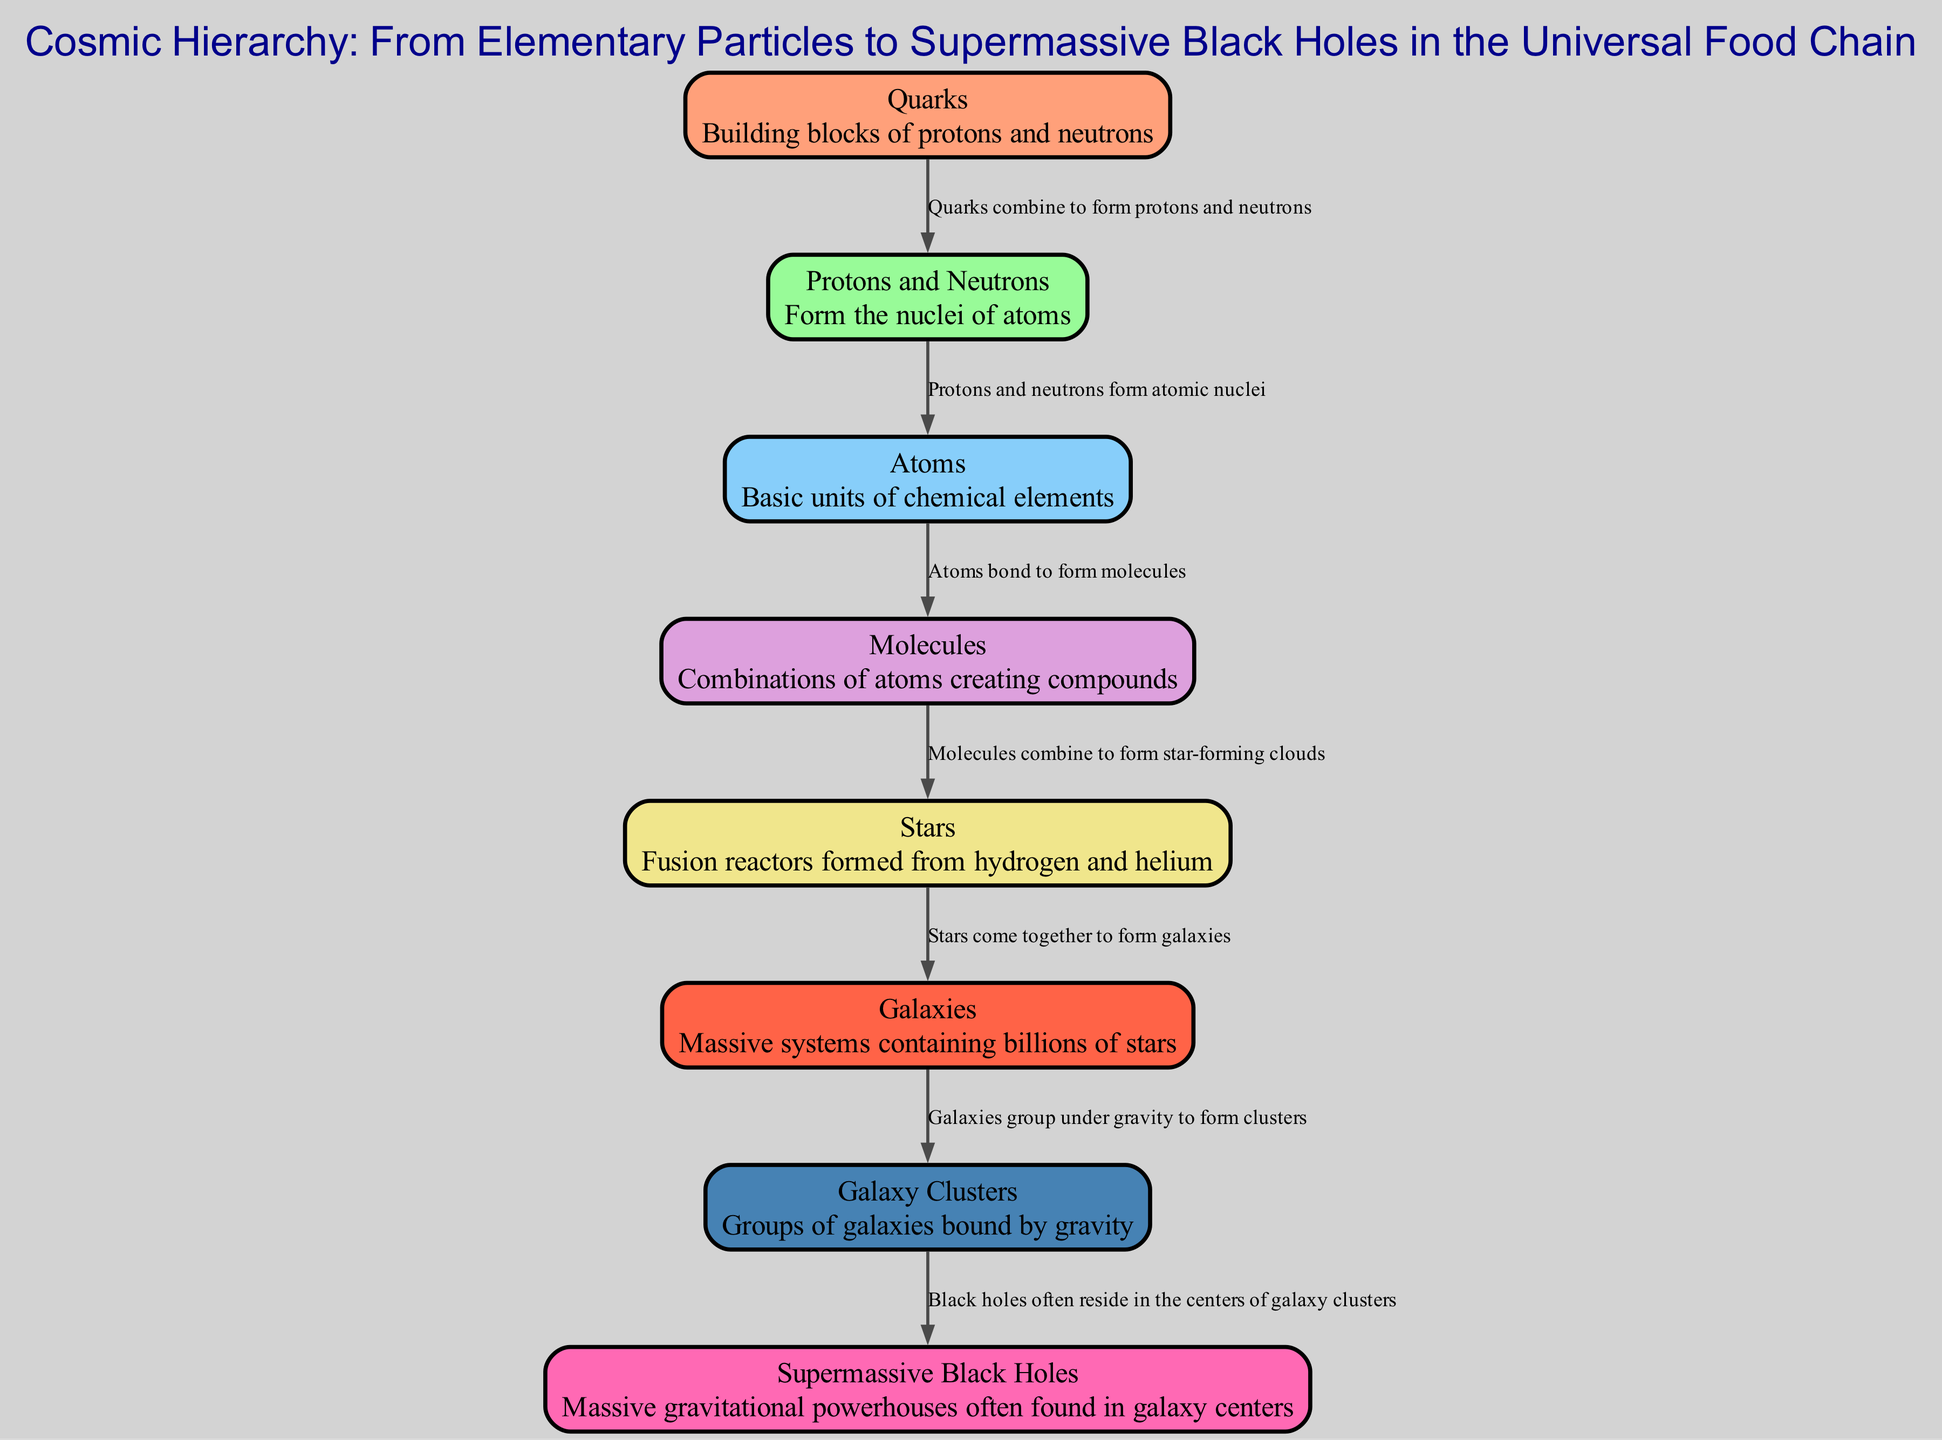What is the first element in the cosmic hierarchy? The first element listed in the diagram is Quarks. It is at level 1, indicating it is the building block of protons and neutrons, which are the next elements in the hierarchy.
Answer: Quarks How many total elements are in the cosmic hierarchy? The diagram lists a total of eight elements, counting from Quarks to Supermassive Black Holes. This can be confirmed by counting the elements presented in the array.
Answer: Eight What is the relationship between Stars and Galaxies? The relationship is described as "Stars come together to form galaxies," indicating that stars are the components necessary for the formation of galaxies.
Answer: Stars come together to form galaxies What forms the nuclei of atoms? The nuclei of atoms are formed by Protons and Neutrons. This information is given directly in the connection between the second and third elements in the diagram.
Answer: Protons and Neutrons Which element is described as "Massive gravitational powerhouses often found in galaxy centers"? This description corresponds to Supermassive Black Holes, which is explicitly stated in the hierarchy of elements.
Answer: Supermassive Black Holes How do Galaxy Clusters relate to Supermassive Black Holes? The relationship is that Supermassive Black Holes often reside in the centers of Galaxy Clusters, indicating a spatial and structural connection. This is noted in the connections section detailing Galaxy Clusters and Supermassive Black Holes.
Answer: Supermassive Black Holes often reside in the centers of Galaxy Clusters What do Atoms combine to form? Atoms bond together to form Molecules, as indicated in the direct connection between these two elements in the diagram.
Answer: Molecules What is the final element in the cosmic hierarchy? The last element in the hierarchy, at level 8, is Supermassive Black Holes, making it the final point in the universal food chain.
Answer: Supermassive Black Holes What is the main purpose of the diagram? The main purpose of the diagram is to illustrate the cosmic hierarchy from Elementary Particles to Supermassive Black Holes in a food chain-like structure. It visually represents how smaller elements build up to form larger cosmic structures.
Answer: To illustrate the cosmic hierarchy 